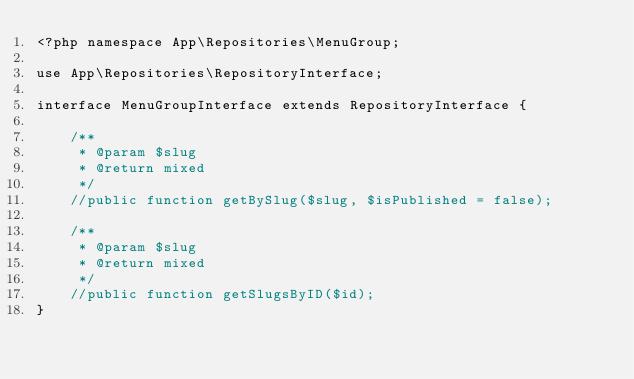<code> <loc_0><loc_0><loc_500><loc_500><_PHP_><?php namespace App\Repositories\MenuGroup;

use App\Repositories\RepositoryInterface;

interface MenuGroupInterface extends RepositoryInterface {

    /**
     * @param $slug
     * @return mixed
     */
    //public function getBySlug($slug, $isPublished = false);

    /**
     * @param $slug
     * @return mixed
     */
    //public function getSlugsByID($id);
}</code> 